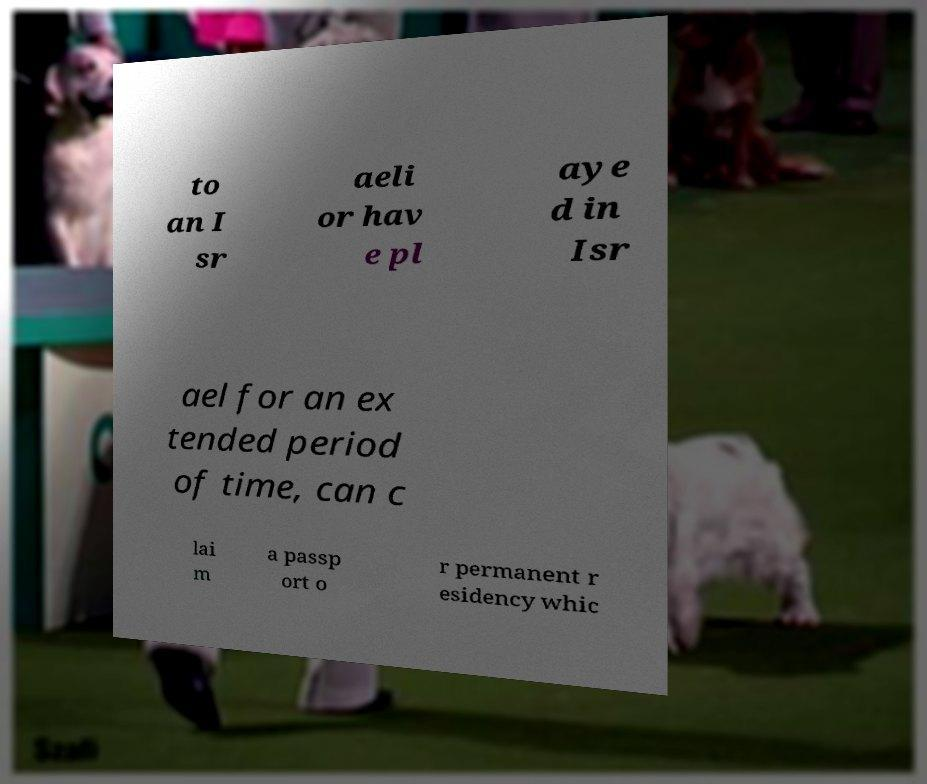For documentation purposes, I need the text within this image transcribed. Could you provide that? to an I sr aeli or hav e pl aye d in Isr ael for an ex tended period of time, can c lai m a passp ort o r permanent r esidency whic 